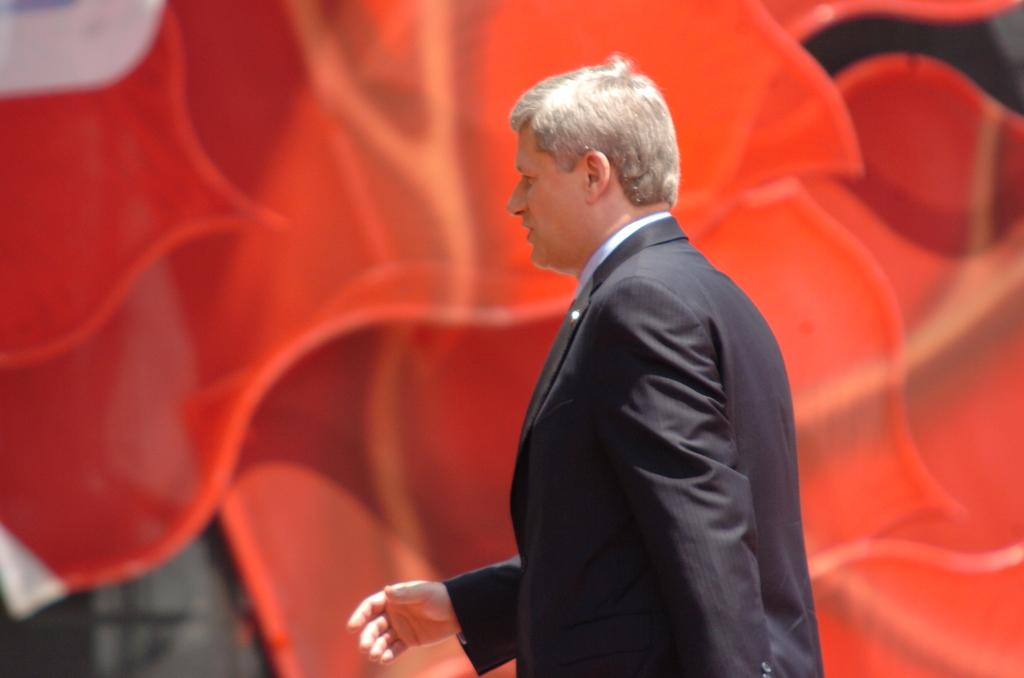What is the main subject of the image? There is a man in the image. What is the man wearing? The man is wearing a black blazer. Where is the man standing? The man is standing on a path. What color is the item visible in the image? There is an orange item visible in the image. What are the man's hobbies, as indicated by the image? The image does not provide information about the man's hobbies. What flavor is the orange item in the image? The image does not provide information about the flavor of the orange item. 